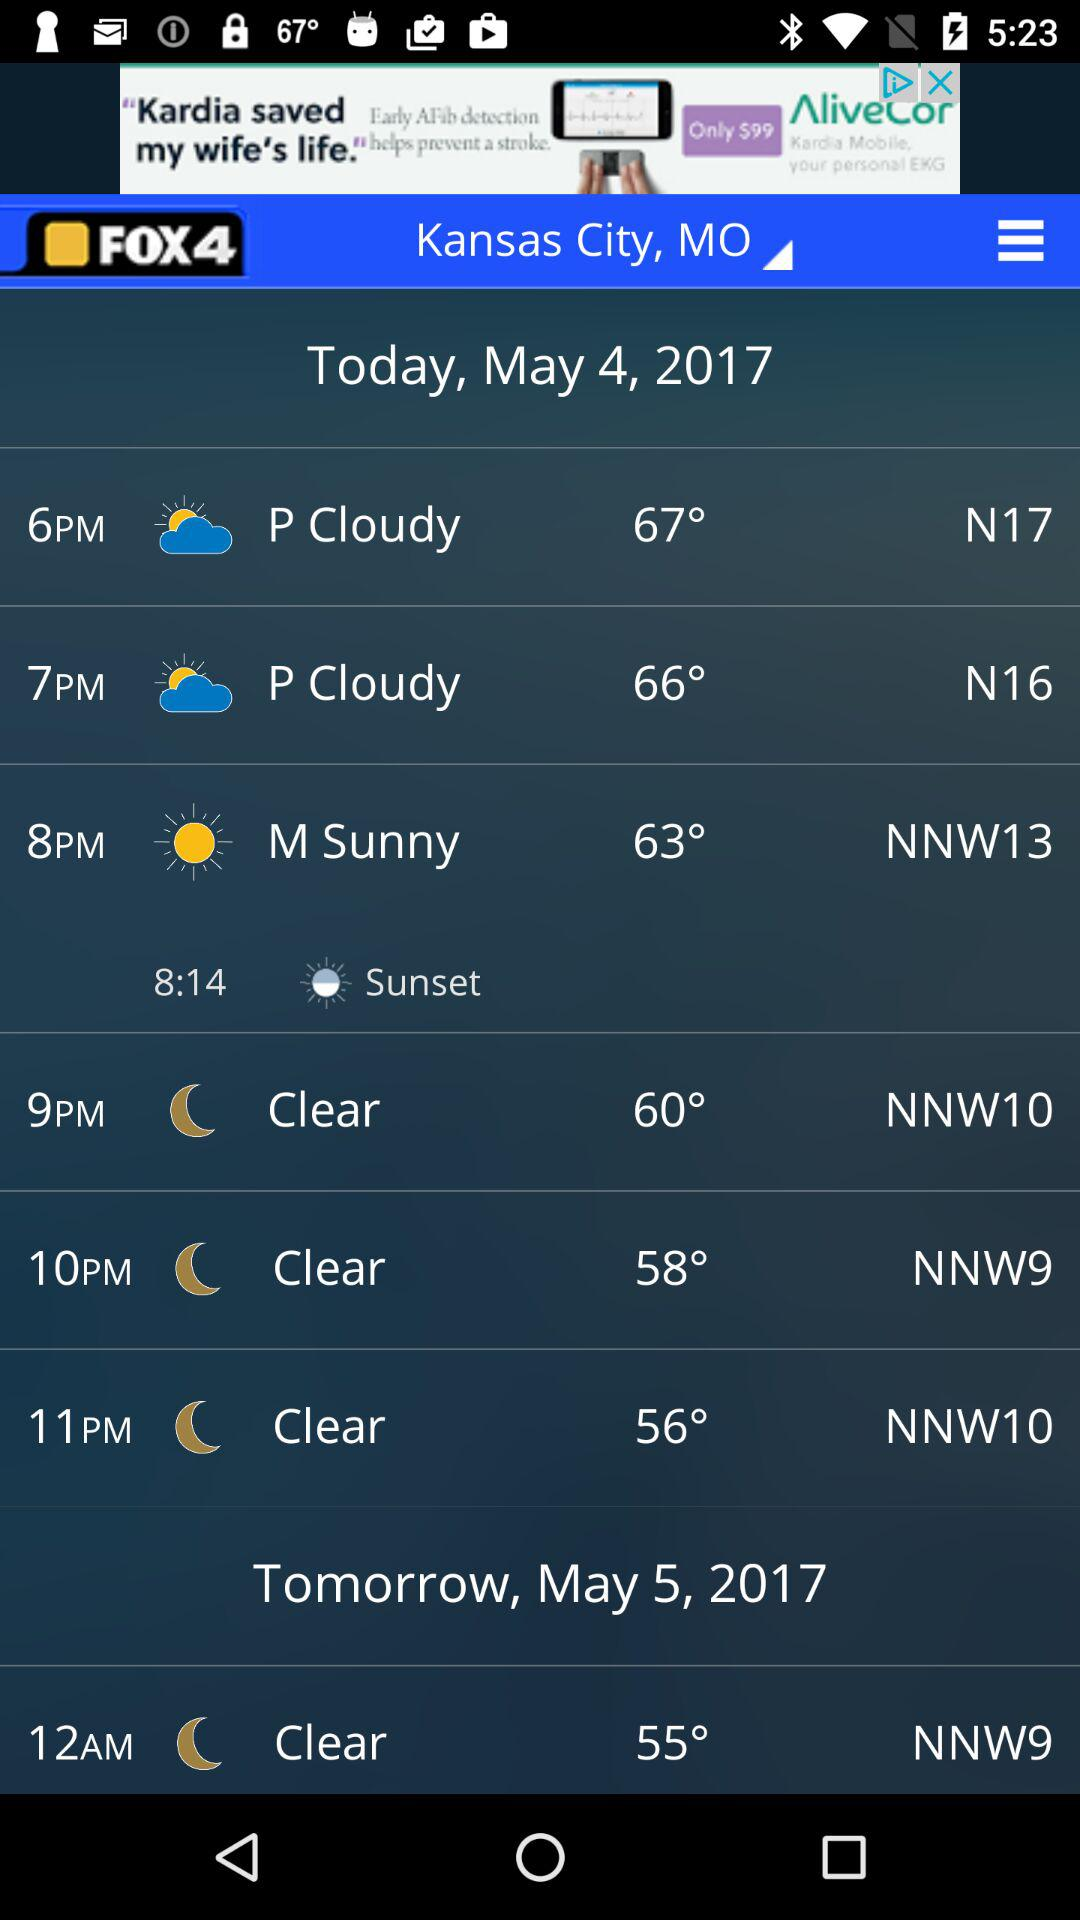How many degrees Fahrenheit is the temperature at 11pm?
Answer the question using a single word or phrase. 56° 